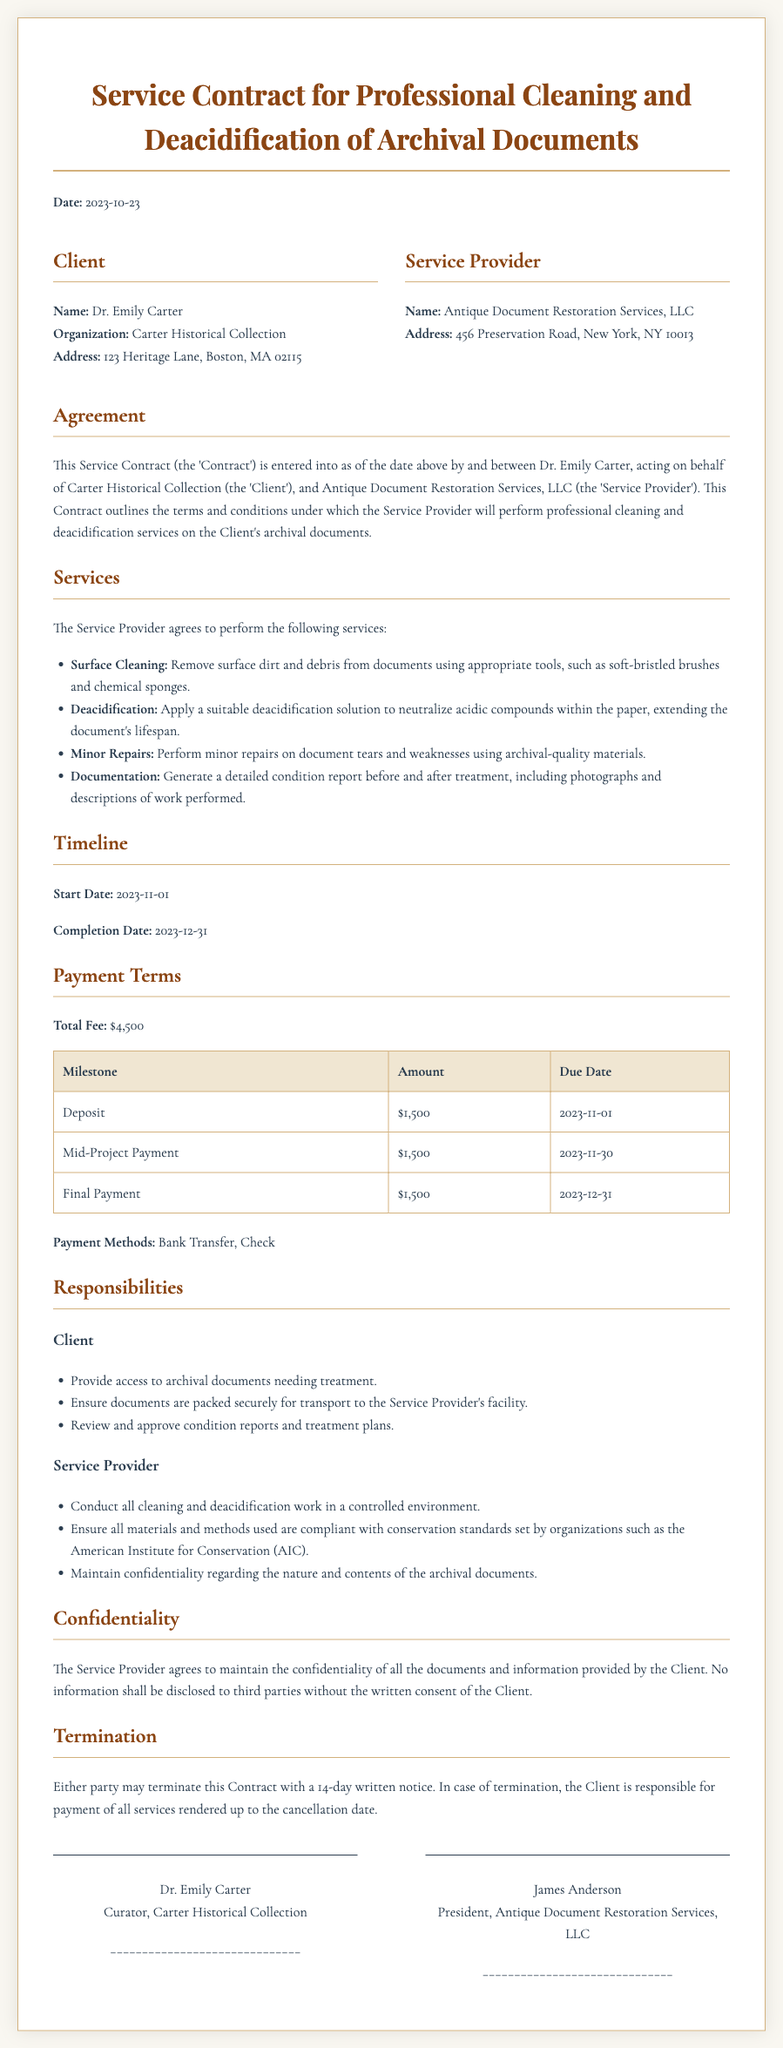What is the date of the contract? The date of the contract is found at the top of the document, mentioned as the "Date."
Answer: 2023-10-23 Who is the Service Provider? The name of the Service Provider is listed under the "Service Provider" section within the document.
Answer: Antique Document Restoration Services, LLC What is the total fee for the services? The total fee can be found under the "Payment Terms" section of the contract.
Answer: $4,500 What is the start date for the services? The start date is clearly stated under the "Timeline" section of the document.
Answer: 2023-11-01 What are the payment methods accepted? The accepted payment methods are listed in the "Payment Terms" section of the contract.
Answer: Bank Transfer, Check What is required from the Client before services commence? This can be found in the "Responsibilities" section, specifically for the Client's obligations.
Answer: Provide access to archival documents needing treatment What must the Service Provider ensure regarding materials and methods? This requirement is outlined in the responsibilities of the Service Provider in the document.
Answer: Compliance with conservation standards How many days notice is required for termination? The notice period for termination is stated under the "Termination" section of the contract.
Answer: 14 days What type of report will be generated after the treatment? The type of report is detailed under the "Services" section regarding documentation.
Answer: Detailed condition report 